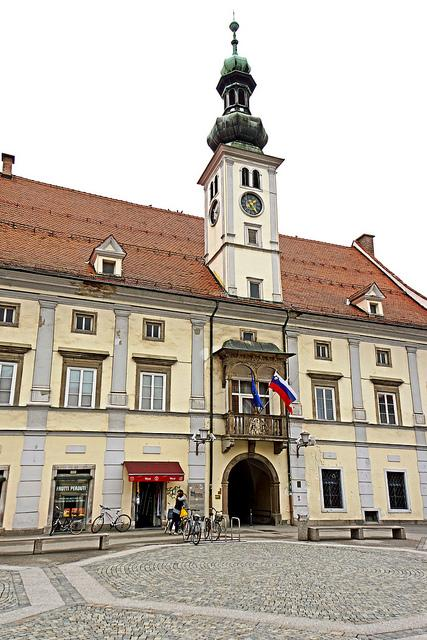What can you use the bike rack for to keep your bike safe? Please explain your reasoning. bike lock. You use a lock to keep the bikes safe. 